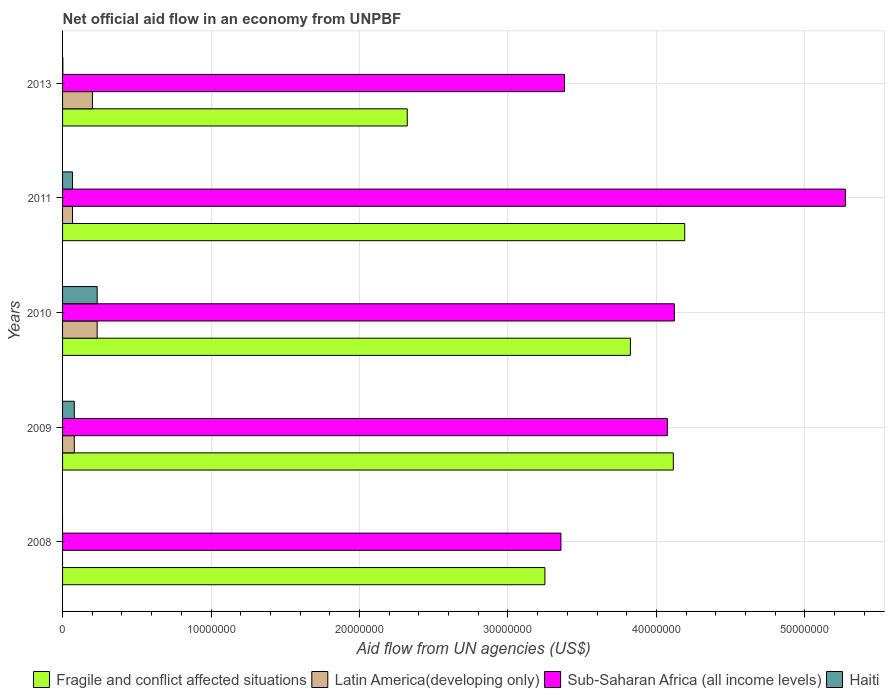Are the number of bars on each tick of the Y-axis equal?
Provide a succinct answer. No. How many bars are there on the 1st tick from the bottom?
Provide a succinct answer. 2. What is the label of the 3rd group of bars from the top?
Ensure brevity in your answer.  2010. What is the net official aid flow in Sub-Saharan Africa (all income levels) in 2010?
Make the answer very short. 4.12e+07. Across all years, what is the maximum net official aid flow in Latin America(developing only)?
Offer a terse response. 2.33e+06. In which year was the net official aid flow in Sub-Saharan Africa (all income levels) maximum?
Ensure brevity in your answer.  2011. What is the total net official aid flow in Latin America(developing only) in the graph?
Give a very brief answer. 5.80e+06. What is the difference between the net official aid flow in Fragile and conflict affected situations in 2009 and that in 2013?
Make the answer very short. 1.79e+07. What is the difference between the net official aid flow in Sub-Saharan Africa (all income levels) in 2010 and the net official aid flow in Haiti in 2013?
Your answer should be compact. 4.12e+07. What is the average net official aid flow in Haiti per year?
Keep it short and to the point. 7.62e+05. In the year 2013, what is the difference between the net official aid flow in Latin America(developing only) and net official aid flow in Fragile and conflict affected situations?
Offer a very short reply. -2.12e+07. What is the ratio of the net official aid flow in Fragile and conflict affected situations in 2009 to that in 2010?
Provide a short and direct response. 1.08. What is the difference between the highest and the lowest net official aid flow in Latin America(developing only)?
Provide a short and direct response. 2.33e+06. In how many years, is the net official aid flow in Sub-Saharan Africa (all income levels) greater than the average net official aid flow in Sub-Saharan Africa (all income levels) taken over all years?
Your response must be concise. 3. Is the sum of the net official aid flow in Haiti in 2009 and 2011 greater than the maximum net official aid flow in Sub-Saharan Africa (all income levels) across all years?
Provide a short and direct response. No. Is it the case that in every year, the sum of the net official aid flow in Haiti and net official aid flow in Latin America(developing only) is greater than the sum of net official aid flow in Sub-Saharan Africa (all income levels) and net official aid flow in Fragile and conflict affected situations?
Offer a terse response. No. Is it the case that in every year, the sum of the net official aid flow in Haiti and net official aid flow in Fragile and conflict affected situations is greater than the net official aid flow in Latin America(developing only)?
Your answer should be compact. Yes. Are all the bars in the graph horizontal?
Your answer should be very brief. Yes. How many years are there in the graph?
Provide a succinct answer. 5. What is the difference between two consecutive major ticks on the X-axis?
Give a very brief answer. 1.00e+07. Where does the legend appear in the graph?
Keep it short and to the point. Bottom right. How many legend labels are there?
Your response must be concise. 4. How are the legend labels stacked?
Your answer should be very brief. Horizontal. What is the title of the graph?
Provide a short and direct response. Net official aid flow in an economy from UNPBF. What is the label or title of the X-axis?
Your answer should be compact. Aid flow from UN agencies (US$). What is the Aid flow from UN agencies (US$) in Fragile and conflict affected situations in 2008?
Your answer should be very brief. 3.25e+07. What is the Aid flow from UN agencies (US$) of Sub-Saharan Africa (all income levels) in 2008?
Your answer should be compact. 3.36e+07. What is the Aid flow from UN agencies (US$) in Haiti in 2008?
Ensure brevity in your answer.  0. What is the Aid flow from UN agencies (US$) of Fragile and conflict affected situations in 2009?
Offer a very short reply. 4.11e+07. What is the Aid flow from UN agencies (US$) of Latin America(developing only) in 2009?
Offer a terse response. 7.90e+05. What is the Aid flow from UN agencies (US$) in Sub-Saharan Africa (all income levels) in 2009?
Offer a terse response. 4.07e+07. What is the Aid flow from UN agencies (US$) of Haiti in 2009?
Ensure brevity in your answer.  7.90e+05. What is the Aid flow from UN agencies (US$) in Fragile and conflict affected situations in 2010?
Ensure brevity in your answer.  3.82e+07. What is the Aid flow from UN agencies (US$) in Latin America(developing only) in 2010?
Offer a very short reply. 2.33e+06. What is the Aid flow from UN agencies (US$) of Sub-Saharan Africa (all income levels) in 2010?
Keep it short and to the point. 4.12e+07. What is the Aid flow from UN agencies (US$) in Haiti in 2010?
Ensure brevity in your answer.  2.33e+06. What is the Aid flow from UN agencies (US$) in Fragile and conflict affected situations in 2011?
Offer a terse response. 4.19e+07. What is the Aid flow from UN agencies (US$) in Latin America(developing only) in 2011?
Offer a very short reply. 6.70e+05. What is the Aid flow from UN agencies (US$) of Sub-Saharan Africa (all income levels) in 2011?
Provide a short and direct response. 5.27e+07. What is the Aid flow from UN agencies (US$) of Haiti in 2011?
Provide a succinct answer. 6.70e+05. What is the Aid flow from UN agencies (US$) in Fragile and conflict affected situations in 2013?
Offer a terse response. 2.32e+07. What is the Aid flow from UN agencies (US$) of Latin America(developing only) in 2013?
Provide a succinct answer. 2.01e+06. What is the Aid flow from UN agencies (US$) of Sub-Saharan Africa (all income levels) in 2013?
Make the answer very short. 3.38e+07. Across all years, what is the maximum Aid flow from UN agencies (US$) of Fragile and conflict affected situations?
Your answer should be compact. 4.19e+07. Across all years, what is the maximum Aid flow from UN agencies (US$) of Latin America(developing only)?
Your answer should be very brief. 2.33e+06. Across all years, what is the maximum Aid flow from UN agencies (US$) in Sub-Saharan Africa (all income levels)?
Make the answer very short. 5.27e+07. Across all years, what is the maximum Aid flow from UN agencies (US$) of Haiti?
Your answer should be compact. 2.33e+06. Across all years, what is the minimum Aid flow from UN agencies (US$) of Fragile and conflict affected situations?
Offer a very short reply. 2.32e+07. Across all years, what is the minimum Aid flow from UN agencies (US$) of Sub-Saharan Africa (all income levels)?
Keep it short and to the point. 3.36e+07. What is the total Aid flow from UN agencies (US$) of Fragile and conflict affected situations in the graph?
Your answer should be very brief. 1.77e+08. What is the total Aid flow from UN agencies (US$) of Latin America(developing only) in the graph?
Provide a short and direct response. 5.80e+06. What is the total Aid flow from UN agencies (US$) of Sub-Saharan Africa (all income levels) in the graph?
Keep it short and to the point. 2.02e+08. What is the total Aid flow from UN agencies (US$) in Haiti in the graph?
Your response must be concise. 3.81e+06. What is the difference between the Aid flow from UN agencies (US$) of Fragile and conflict affected situations in 2008 and that in 2009?
Your response must be concise. -8.65e+06. What is the difference between the Aid flow from UN agencies (US$) of Sub-Saharan Africa (all income levels) in 2008 and that in 2009?
Provide a short and direct response. -7.17e+06. What is the difference between the Aid flow from UN agencies (US$) of Fragile and conflict affected situations in 2008 and that in 2010?
Provide a short and direct response. -5.76e+06. What is the difference between the Aid flow from UN agencies (US$) of Sub-Saharan Africa (all income levels) in 2008 and that in 2010?
Provide a succinct answer. -7.64e+06. What is the difference between the Aid flow from UN agencies (US$) in Fragile and conflict affected situations in 2008 and that in 2011?
Your response must be concise. -9.42e+06. What is the difference between the Aid flow from UN agencies (US$) in Sub-Saharan Africa (all income levels) in 2008 and that in 2011?
Provide a short and direct response. -1.92e+07. What is the difference between the Aid flow from UN agencies (US$) of Fragile and conflict affected situations in 2008 and that in 2013?
Your answer should be compact. 9.27e+06. What is the difference between the Aid flow from UN agencies (US$) in Sub-Saharan Africa (all income levels) in 2008 and that in 2013?
Offer a very short reply. -2.40e+05. What is the difference between the Aid flow from UN agencies (US$) of Fragile and conflict affected situations in 2009 and that in 2010?
Offer a terse response. 2.89e+06. What is the difference between the Aid flow from UN agencies (US$) in Latin America(developing only) in 2009 and that in 2010?
Ensure brevity in your answer.  -1.54e+06. What is the difference between the Aid flow from UN agencies (US$) of Sub-Saharan Africa (all income levels) in 2009 and that in 2010?
Ensure brevity in your answer.  -4.70e+05. What is the difference between the Aid flow from UN agencies (US$) of Haiti in 2009 and that in 2010?
Your response must be concise. -1.54e+06. What is the difference between the Aid flow from UN agencies (US$) of Fragile and conflict affected situations in 2009 and that in 2011?
Provide a succinct answer. -7.70e+05. What is the difference between the Aid flow from UN agencies (US$) of Latin America(developing only) in 2009 and that in 2011?
Offer a terse response. 1.20e+05. What is the difference between the Aid flow from UN agencies (US$) in Sub-Saharan Africa (all income levels) in 2009 and that in 2011?
Ensure brevity in your answer.  -1.20e+07. What is the difference between the Aid flow from UN agencies (US$) of Haiti in 2009 and that in 2011?
Your response must be concise. 1.20e+05. What is the difference between the Aid flow from UN agencies (US$) in Fragile and conflict affected situations in 2009 and that in 2013?
Offer a very short reply. 1.79e+07. What is the difference between the Aid flow from UN agencies (US$) in Latin America(developing only) in 2009 and that in 2013?
Offer a very short reply. -1.22e+06. What is the difference between the Aid flow from UN agencies (US$) of Sub-Saharan Africa (all income levels) in 2009 and that in 2013?
Offer a very short reply. 6.93e+06. What is the difference between the Aid flow from UN agencies (US$) in Haiti in 2009 and that in 2013?
Your answer should be compact. 7.70e+05. What is the difference between the Aid flow from UN agencies (US$) of Fragile and conflict affected situations in 2010 and that in 2011?
Provide a short and direct response. -3.66e+06. What is the difference between the Aid flow from UN agencies (US$) in Latin America(developing only) in 2010 and that in 2011?
Your answer should be compact. 1.66e+06. What is the difference between the Aid flow from UN agencies (US$) in Sub-Saharan Africa (all income levels) in 2010 and that in 2011?
Ensure brevity in your answer.  -1.15e+07. What is the difference between the Aid flow from UN agencies (US$) of Haiti in 2010 and that in 2011?
Keep it short and to the point. 1.66e+06. What is the difference between the Aid flow from UN agencies (US$) in Fragile and conflict affected situations in 2010 and that in 2013?
Offer a very short reply. 1.50e+07. What is the difference between the Aid flow from UN agencies (US$) in Latin America(developing only) in 2010 and that in 2013?
Your answer should be very brief. 3.20e+05. What is the difference between the Aid flow from UN agencies (US$) in Sub-Saharan Africa (all income levels) in 2010 and that in 2013?
Your answer should be compact. 7.40e+06. What is the difference between the Aid flow from UN agencies (US$) of Haiti in 2010 and that in 2013?
Provide a succinct answer. 2.31e+06. What is the difference between the Aid flow from UN agencies (US$) of Fragile and conflict affected situations in 2011 and that in 2013?
Your response must be concise. 1.87e+07. What is the difference between the Aid flow from UN agencies (US$) of Latin America(developing only) in 2011 and that in 2013?
Keep it short and to the point. -1.34e+06. What is the difference between the Aid flow from UN agencies (US$) in Sub-Saharan Africa (all income levels) in 2011 and that in 2013?
Offer a terse response. 1.89e+07. What is the difference between the Aid flow from UN agencies (US$) in Haiti in 2011 and that in 2013?
Your answer should be compact. 6.50e+05. What is the difference between the Aid flow from UN agencies (US$) of Fragile and conflict affected situations in 2008 and the Aid flow from UN agencies (US$) of Latin America(developing only) in 2009?
Offer a very short reply. 3.17e+07. What is the difference between the Aid flow from UN agencies (US$) of Fragile and conflict affected situations in 2008 and the Aid flow from UN agencies (US$) of Sub-Saharan Africa (all income levels) in 2009?
Your response must be concise. -8.25e+06. What is the difference between the Aid flow from UN agencies (US$) of Fragile and conflict affected situations in 2008 and the Aid flow from UN agencies (US$) of Haiti in 2009?
Give a very brief answer. 3.17e+07. What is the difference between the Aid flow from UN agencies (US$) of Sub-Saharan Africa (all income levels) in 2008 and the Aid flow from UN agencies (US$) of Haiti in 2009?
Make the answer very short. 3.28e+07. What is the difference between the Aid flow from UN agencies (US$) of Fragile and conflict affected situations in 2008 and the Aid flow from UN agencies (US$) of Latin America(developing only) in 2010?
Provide a short and direct response. 3.02e+07. What is the difference between the Aid flow from UN agencies (US$) in Fragile and conflict affected situations in 2008 and the Aid flow from UN agencies (US$) in Sub-Saharan Africa (all income levels) in 2010?
Keep it short and to the point. -8.72e+06. What is the difference between the Aid flow from UN agencies (US$) in Fragile and conflict affected situations in 2008 and the Aid flow from UN agencies (US$) in Haiti in 2010?
Provide a short and direct response. 3.02e+07. What is the difference between the Aid flow from UN agencies (US$) of Sub-Saharan Africa (all income levels) in 2008 and the Aid flow from UN agencies (US$) of Haiti in 2010?
Offer a very short reply. 3.12e+07. What is the difference between the Aid flow from UN agencies (US$) of Fragile and conflict affected situations in 2008 and the Aid flow from UN agencies (US$) of Latin America(developing only) in 2011?
Provide a short and direct response. 3.18e+07. What is the difference between the Aid flow from UN agencies (US$) of Fragile and conflict affected situations in 2008 and the Aid flow from UN agencies (US$) of Sub-Saharan Africa (all income levels) in 2011?
Give a very brief answer. -2.02e+07. What is the difference between the Aid flow from UN agencies (US$) of Fragile and conflict affected situations in 2008 and the Aid flow from UN agencies (US$) of Haiti in 2011?
Provide a succinct answer. 3.18e+07. What is the difference between the Aid flow from UN agencies (US$) in Sub-Saharan Africa (all income levels) in 2008 and the Aid flow from UN agencies (US$) in Haiti in 2011?
Your answer should be compact. 3.29e+07. What is the difference between the Aid flow from UN agencies (US$) of Fragile and conflict affected situations in 2008 and the Aid flow from UN agencies (US$) of Latin America(developing only) in 2013?
Offer a terse response. 3.05e+07. What is the difference between the Aid flow from UN agencies (US$) of Fragile and conflict affected situations in 2008 and the Aid flow from UN agencies (US$) of Sub-Saharan Africa (all income levels) in 2013?
Provide a succinct answer. -1.32e+06. What is the difference between the Aid flow from UN agencies (US$) in Fragile and conflict affected situations in 2008 and the Aid flow from UN agencies (US$) in Haiti in 2013?
Give a very brief answer. 3.25e+07. What is the difference between the Aid flow from UN agencies (US$) in Sub-Saharan Africa (all income levels) in 2008 and the Aid flow from UN agencies (US$) in Haiti in 2013?
Your response must be concise. 3.36e+07. What is the difference between the Aid flow from UN agencies (US$) in Fragile and conflict affected situations in 2009 and the Aid flow from UN agencies (US$) in Latin America(developing only) in 2010?
Your answer should be compact. 3.88e+07. What is the difference between the Aid flow from UN agencies (US$) in Fragile and conflict affected situations in 2009 and the Aid flow from UN agencies (US$) in Haiti in 2010?
Provide a succinct answer. 3.88e+07. What is the difference between the Aid flow from UN agencies (US$) in Latin America(developing only) in 2009 and the Aid flow from UN agencies (US$) in Sub-Saharan Africa (all income levels) in 2010?
Provide a succinct answer. -4.04e+07. What is the difference between the Aid flow from UN agencies (US$) of Latin America(developing only) in 2009 and the Aid flow from UN agencies (US$) of Haiti in 2010?
Your answer should be very brief. -1.54e+06. What is the difference between the Aid flow from UN agencies (US$) of Sub-Saharan Africa (all income levels) in 2009 and the Aid flow from UN agencies (US$) of Haiti in 2010?
Your response must be concise. 3.84e+07. What is the difference between the Aid flow from UN agencies (US$) of Fragile and conflict affected situations in 2009 and the Aid flow from UN agencies (US$) of Latin America(developing only) in 2011?
Make the answer very short. 4.05e+07. What is the difference between the Aid flow from UN agencies (US$) of Fragile and conflict affected situations in 2009 and the Aid flow from UN agencies (US$) of Sub-Saharan Africa (all income levels) in 2011?
Provide a succinct answer. -1.16e+07. What is the difference between the Aid flow from UN agencies (US$) of Fragile and conflict affected situations in 2009 and the Aid flow from UN agencies (US$) of Haiti in 2011?
Offer a terse response. 4.05e+07. What is the difference between the Aid flow from UN agencies (US$) in Latin America(developing only) in 2009 and the Aid flow from UN agencies (US$) in Sub-Saharan Africa (all income levels) in 2011?
Your answer should be very brief. -5.19e+07. What is the difference between the Aid flow from UN agencies (US$) of Latin America(developing only) in 2009 and the Aid flow from UN agencies (US$) of Haiti in 2011?
Your answer should be compact. 1.20e+05. What is the difference between the Aid flow from UN agencies (US$) in Sub-Saharan Africa (all income levels) in 2009 and the Aid flow from UN agencies (US$) in Haiti in 2011?
Ensure brevity in your answer.  4.01e+07. What is the difference between the Aid flow from UN agencies (US$) in Fragile and conflict affected situations in 2009 and the Aid flow from UN agencies (US$) in Latin America(developing only) in 2013?
Ensure brevity in your answer.  3.91e+07. What is the difference between the Aid flow from UN agencies (US$) in Fragile and conflict affected situations in 2009 and the Aid flow from UN agencies (US$) in Sub-Saharan Africa (all income levels) in 2013?
Give a very brief answer. 7.33e+06. What is the difference between the Aid flow from UN agencies (US$) in Fragile and conflict affected situations in 2009 and the Aid flow from UN agencies (US$) in Haiti in 2013?
Keep it short and to the point. 4.11e+07. What is the difference between the Aid flow from UN agencies (US$) of Latin America(developing only) in 2009 and the Aid flow from UN agencies (US$) of Sub-Saharan Africa (all income levels) in 2013?
Offer a very short reply. -3.30e+07. What is the difference between the Aid flow from UN agencies (US$) of Latin America(developing only) in 2009 and the Aid flow from UN agencies (US$) of Haiti in 2013?
Ensure brevity in your answer.  7.70e+05. What is the difference between the Aid flow from UN agencies (US$) in Sub-Saharan Africa (all income levels) in 2009 and the Aid flow from UN agencies (US$) in Haiti in 2013?
Provide a succinct answer. 4.07e+07. What is the difference between the Aid flow from UN agencies (US$) in Fragile and conflict affected situations in 2010 and the Aid flow from UN agencies (US$) in Latin America(developing only) in 2011?
Your response must be concise. 3.76e+07. What is the difference between the Aid flow from UN agencies (US$) in Fragile and conflict affected situations in 2010 and the Aid flow from UN agencies (US$) in Sub-Saharan Africa (all income levels) in 2011?
Give a very brief answer. -1.45e+07. What is the difference between the Aid flow from UN agencies (US$) in Fragile and conflict affected situations in 2010 and the Aid flow from UN agencies (US$) in Haiti in 2011?
Ensure brevity in your answer.  3.76e+07. What is the difference between the Aid flow from UN agencies (US$) of Latin America(developing only) in 2010 and the Aid flow from UN agencies (US$) of Sub-Saharan Africa (all income levels) in 2011?
Offer a very short reply. -5.04e+07. What is the difference between the Aid flow from UN agencies (US$) in Latin America(developing only) in 2010 and the Aid flow from UN agencies (US$) in Haiti in 2011?
Your answer should be compact. 1.66e+06. What is the difference between the Aid flow from UN agencies (US$) in Sub-Saharan Africa (all income levels) in 2010 and the Aid flow from UN agencies (US$) in Haiti in 2011?
Your response must be concise. 4.05e+07. What is the difference between the Aid flow from UN agencies (US$) of Fragile and conflict affected situations in 2010 and the Aid flow from UN agencies (US$) of Latin America(developing only) in 2013?
Your response must be concise. 3.62e+07. What is the difference between the Aid flow from UN agencies (US$) in Fragile and conflict affected situations in 2010 and the Aid flow from UN agencies (US$) in Sub-Saharan Africa (all income levels) in 2013?
Give a very brief answer. 4.44e+06. What is the difference between the Aid flow from UN agencies (US$) of Fragile and conflict affected situations in 2010 and the Aid flow from UN agencies (US$) of Haiti in 2013?
Offer a very short reply. 3.82e+07. What is the difference between the Aid flow from UN agencies (US$) in Latin America(developing only) in 2010 and the Aid flow from UN agencies (US$) in Sub-Saharan Africa (all income levels) in 2013?
Provide a succinct answer. -3.15e+07. What is the difference between the Aid flow from UN agencies (US$) of Latin America(developing only) in 2010 and the Aid flow from UN agencies (US$) of Haiti in 2013?
Give a very brief answer. 2.31e+06. What is the difference between the Aid flow from UN agencies (US$) of Sub-Saharan Africa (all income levels) in 2010 and the Aid flow from UN agencies (US$) of Haiti in 2013?
Give a very brief answer. 4.12e+07. What is the difference between the Aid flow from UN agencies (US$) of Fragile and conflict affected situations in 2011 and the Aid flow from UN agencies (US$) of Latin America(developing only) in 2013?
Offer a very short reply. 3.99e+07. What is the difference between the Aid flow from UN agencies (US$) in Fragile and conflict affected situations in 2011 and the Aid flow from UN agencies (US$) in Sub-Saharan Africa (all income levels) in 2013?
Ensure brevity in your answer.  8.10e+06. What is the difference between the Aid flow from UN agencies (US$) in Fragile and conflict affected situations in 2011 and the Aid flow from UN agencies (US$) in Haiti in 2013?
Your answer should be very brief. 4.19e+07. What is the difference between the Aid flow from UN agencies (US$) in Latin America(developing only) in 2011 and the Aid flow from UN agencies (US$) in Sub-Saharan Africa (all income levels) in 2013?
Provide a short and direct response. -3.31e+07. What is the difference between the Aid flow from UN agencies (US$) in Latin America(developing only) in 2011 and the Aid flow from UN agencies (US$) in Haiti in 2013?
Keep it short and to the point. 6.50e+05. What is the difference between the Aid flow from UN agencies (US$) in Sub-Saharan Africa (all income levels) in 2011 and the Aid flow from UN agencies (US$) in Haiti in 2013?
Ensure brevity in your answer.  5.27e+07. What is the average Aid flow from UN agencies (US$) of Fragile and conflict affected situations per year?
Provide a short and direct response. 3.54e+07. What is the average Aid flow from UN agencies (US$) in Latin America(developing only) per year?
Keep it short and to the point. 1.16e+06. What is the average Aid flow from UN agencies (US$) of Sub-Saharan Africa (all income levels) per year?
Keep it short and to the point. 4.04e+07. What is the average Aid flow from UN agencies (US$) of Haiti per year?
Your answer should be compact. 7.62e+05. In the year 2008, what is the difference between the Aid flow from UN agencies (US$) of Fragile and conflict affected situations and Aid flow from UN agencies (US$) of Sub-Saharan Africa (all income levels)?
Offer a terse response. -1.08e+06. In the year 2009, what is the difference between the Aid flow from UN agencies (US$) of Fragile and conflict affected situations and Aid flow from UN agencies (US$) of Latin America(developing only)?
Your answer should be very brief. 4.04e+07. In the year 2009, what is the difference between the Aid flow from UN agencies (US$) of Fragile and conflict affected situations and Aid flow from UN agencies (US$) of Haiti?
Give a very brief answer. 4.04e+07. In the year 2009, what is the difference between the Aid flow from UN agencies (US$) in Latin America(developing only) and Aid flow from UN agencies (US$) in Sub-Saharan Africa (all income levels)?
Make the answer very short. -4.00e+07. In the year 2009, what is the difference between the Aid flow from UN agencies (US$) in Sub-Saharan Africa (all income levels) and Aid flow from UN agencies (US$) in Haiti?
Give a very brief answer. 4.00e+07. In the year 2010, what is the difference between the Aid flow from UN agencies (US$) in Fragile and conflict affected situations and Aid flow from UN agencies (US$) in Latin America(developing only)?
Offer a terse response. 3.59e+07. In the year 2010, what is the difference between the Aid flow from UN agencies (US$) in Fragile and conflict affected situations and Aid flow from UN agencies (US$) in Sub-Saharan Africa (all income levels)?
Keep it short and to the point. -2.96e+06. In the year 2010, what is the difference between the Aid flow from UN agencies (US$) of Fragile and conflict affected situations and Aid flow from UN agencies (US$) of Haiti?
Your answer should be very brief. 3.59e+07. In the year 2010, what is the difference between the Aid flow from UN agencies (US$) of Latin America(developing only) and Aid flow from UN agencies (US$) of Sub-Saharan Africa (all income levels)?
Ensure brevity in your answer.  -3.89e+07. In the year 2010, what is the difference between the Aid flow from UN agencies (US$) in Sub-Saharan Africa (all income levels) and Aid flow from UN agencies (US$) in Haiti?
Your response must be concise. 3.89e+07. In the year 2011, what is the difference between the Aid flow from UN agencies (US$) of Fragile and conflict affected situations and Aid flow from UN agencies (US$) of Latin America(developing only)?
Offer a very short reply. 4.12e+07. In the year 2011, what is the difference between the Aid flow from UN agencies (US$) in Fragile and conflict affected situations and Aid flow from UN agencies (US$) in Sub-Saharan Africa (all income levels)?
Give a very brief answer. -1.08e+07. In the year 2011, what is the difference between the Aid flow from UN agencies (US$) in Fragile and conflict affected situations and Aid flow from UN agencies (US$) in Haiti?
Provide a short and direct response. 4.12e+07. In the year 2011, what is the difference between the Aid flow from UN agencies (US$) of Latin America(developing only) and Aid flow from UN agencies (US$) of Sub-Saharan Africa (all income levels)?
Offer a very short reply. -5.21e+07. In the year 2011, what is the difference between the Aid flow from UN agencies (US$) of Latin America(developing only) and Aid flow from UN agencies (US$) of Haiti?
Your answer should be compact. 0. In the year 2011, what is the difference between the Aid flow from UN agencies (US$) in Sub-Saharan Africa (all income levels) and Aid flow from UN agencies (US$) in Haiti?
Ensure brevity in your answer.  5.21e+07. In the year 2013, what is the difference between the Aid flow from UN agencies (US$) in Fragile and conflict affected situations and Aid flow from UN agencies (US$) in Latin America(developing only)?
Provide a short and direct response. 2.12e+07. In the year 2013, what is the difference between the Aid flow from UN agencies (US$) in Fragile and conflict affected situations and Aid flow from UN agencies (US$) in Sub-Saharan Africa (all income levels)?
Keep it short and to the point. -1.06e+07. In the year 2013, what is the difference between the Aid flow from UN agencies (US$) of Fragile and conflict affected situations and Aid flow from UN agencies (US$) of Haiti?
Give a very brief answer. 2.32e+07. In the year 2013, what is the difference between the Aid flow from UN agencies (US$) in Latin America(developing only) and Aid flow from UN agencies (US$) in Sub-Saharan Africa (all income levels)?
Your answer should be compact. -3.18e+07. In the year 2013, what is the difference between the Aid flow from UN agencies (US$) of Latin America(developing only) and Aid flow from UN agencies (US$) of Haiti?
Ensure brevity in your answer.  1.99e+06. In the year 2013, what is the difference between the Aid flow from UN agencies (US$) of Sub-Saharan Africa (all income levels) and Aid flow from UN agencies (US$) of Haiti?
Your answer should be very brief. 3.38e+07. What is the ratio of the Aid flow from UN agencies (US$) in Fragile and conflict affected situations in 2008 to that in 2009?
Give a very brief answer. 0.79. What is the ratio of the Aid flow from UN agencies (US$) in Sub-Saharan Africa (all income levels) in 2008 to that in 2009?
Keep it short and to the point. 0.82. What is the ratio of the Aid flow from UN agencies (US$) of Fragile and conflict affected situations in 2008 to that in 2010?
Give a very brief answer. 0.85. What is the ratio of the Aid flow from UN agencies (US$) in Sub-Saharan Africa (all income levels) in 2008 to that in 2010?
Ensure brevity in your answer.  0.81. What is the ratio of the Aid flow from UN agencies (US$) in Fragile and conflict affected situations in 2008 to that in 2011?
Make the answer very short. 0.78. What is the ratio of the Aid flow from UN agencies (US$) in Sub-Saharan Africa (all income levels) in 2008 to that in 2011?
Provide a short and direct response. 0.64. What is the ratio of the Aid flow from UN agencies (US$) in Fragile and conflict affected situations in 2008 to that in 2013?
Offer a terse response. 1.4. What is the ratio of the Aid flow from UN agencies (US$) of Fragile and conflict affected situations in 2009 to that in 2010?
Make the answer very short. 1.08. What is the ratio of the Aid flow from UN agencies (US$) in Latin America(developing only) in 2009 to that in 2010?
Your response must be concise. 0.34. What is the ratio of the Aid flow from UN agencies (US$) of Sub-Saharan Africa (all income levels) in 2009 to that in 2010?
Your answer should be very brief. 0.99. What is the ratio of the Aid flow from UN agencies (US$) in Haiti in 2009 to that in 2010?
Provide a short and direct response. 0.34. What is the ratio of the Aid flow from UN agencies (US$) of Fragile and conflict affected situations in 2009 to that in 2011?
Make the answer very short. 0.98. What is the ratio of the Aid flow from UN agencies (US$) in Latin America(developing only) in 2009 to that in 2011?
Make the answer very short. 1.18. What is the ratio of the Aid flow from UN agencies (US$) of Sub-Saharan Africa (all income levels) in 2009 to that in 2011?
Offer a very short reply. 0.77. What is the ratio of the Aid flow from UN agencies (US$) of Haiti in 2009 to that in 2011?
Provide a short and direct response. 1.18. What is the ratio of the Aid flow from UN agencies (US$) in Fragile and conflict affected situations in 2009 to that in 2013?
Your response must be concise. 1.77. What is the ratio of the Aid flow from UN agencies (US$) in Latin America(developing only) in 2009 to that in 2013?
Give a very brief answer. 0.39. What is the ratio of the Aid flow from UN agencies (US$) in Sub-Saharan Africa (all income levels) in 2009 to that in 2013?
Offer a very short reply. 1.21. What is the ratio of the Aid flow from UN agencies (US$) of Haiti in 2009 to that in 2013?
Your response must be concise. 39.5. What is the ratio of the Aid flow from UN agencies (US$) of Fragile and conflict affected situations in 2010 to that in 2011?
Provide a short and direct response. 0.91. What is the ratio of the Aid flow from UN agencies (US$) in Latin America(developing only) in 2010 to that in 2011?
Keep it short and to the point. 3.48. What is the ratio of the Aid flow from UN agencies (US$) of Sub-Saharan Africa (all income levels) in 2010 to that in 2011?
Keep it short and to the point. 0.78. What is the ratio of the Aid flow from UN agencies (US$) of Haiti in 2010 to that in 2011?
Your answer should be compact. 3.48. What is the ratio of the Aid flow from UN agencies (US$) of Fragile and conflict affected situations in 2010 to that in 2013?
Your response must be concise. 1.65. What is the ratio of the Aid flow from UN agencies (US$) of Latin America(developing only) in 2010 to that in 2013?
Provide a short and direct response. 1.16. What is the ratio of the Aid flow from UN agencies (US$) of Sub-Saharan Africa (all income levels) in 2010 to that in 2013?
Your answer should be very brief. 1.22. What is the ratio of the Aid flow from UN agencies (US$) of Haiti in 2010 to that in 2013?
Provide a succinct answer. 116.5. What is the ratio of the Aid flow from UN agencies (US$) of Fragile and conflict affected situations in 2011 to that in 2013?
Ensure brevity in your answer.  1.8. What is the ratio of the Aid flow from UN agencies (US$) of Latin America(developing only) in 2011 to that in 2013?
Your answer should be compact. 0.33. What is the ratio of the Aid flow from UN agencies (US$) of Sub-Saharan Africa (all income levels) in 2011 to that in 2013?
Your answer should be very brief. 1.56. What is the ratio of the Aid flow from UN agencies (US$) of Haiti in 2011 to that in 2013?
Keep it short and to the point. 33.5. What is the difference between the highest and the second highest Aid flow from UN agencies (US$) of Fragile and conflict affected situations?
Give a very brief answer. 7.70e+05. What is the difference between the highest and the second highest Aid flow from UN agencies (US$) of Sub-Saharan Africa (all income levels)?
Provide a short and direct response. 1.15e+07. What is the difference between the highest and the second highest Aid flow from UN agencies (US$) of Haiti?
Offer a terse response. 1.54e+06. What is the difference between the highest and the lowest Aid flow from UN agencies (US$) in Fragile and conflict affected situations?
Provide a succinct answer. 1.87e+07. What is the difference between the highest and the lowest Aid flow from UN agencies (US$) in Latin America(developing only)?
Make the answer very short. 2.33e+06. What is the difference between the highest and the lowest Aid flow from UN agencies (US$) of Sub-Saharan Africa (all income levels)?
Your answer should be compact. 1.92e+07. What is the difference between the highest and the lowest Aid flow from UN agencies (US$) of Haiti?
Give a very brief answer. 2.33e+06. 